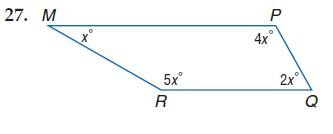Answer the mathemtical geometry problem and directly provide the correct option letter.
Question: Find m \angle M.
Choices: A: 30 B: 60 C: 120 D: 150 A 